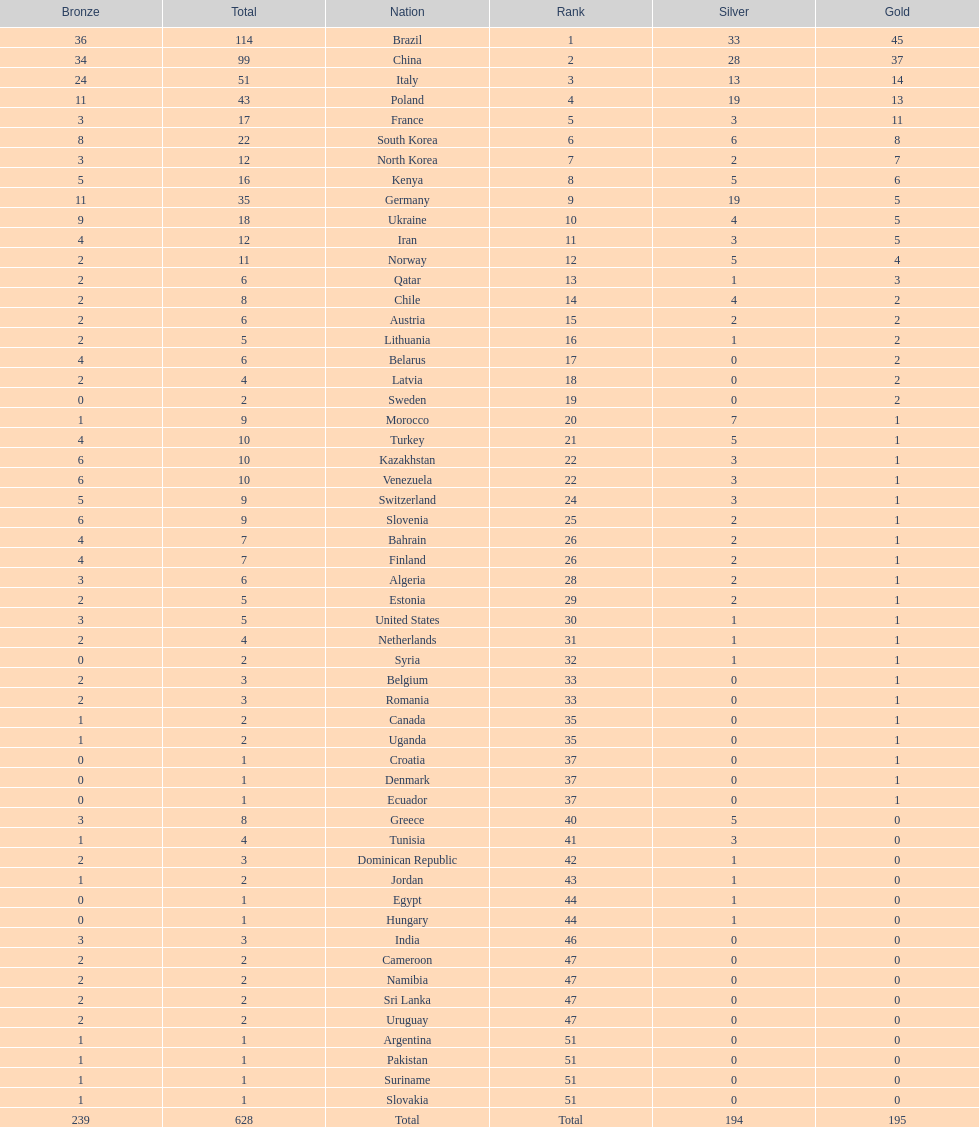How many gold medals did germany earn? 5. 